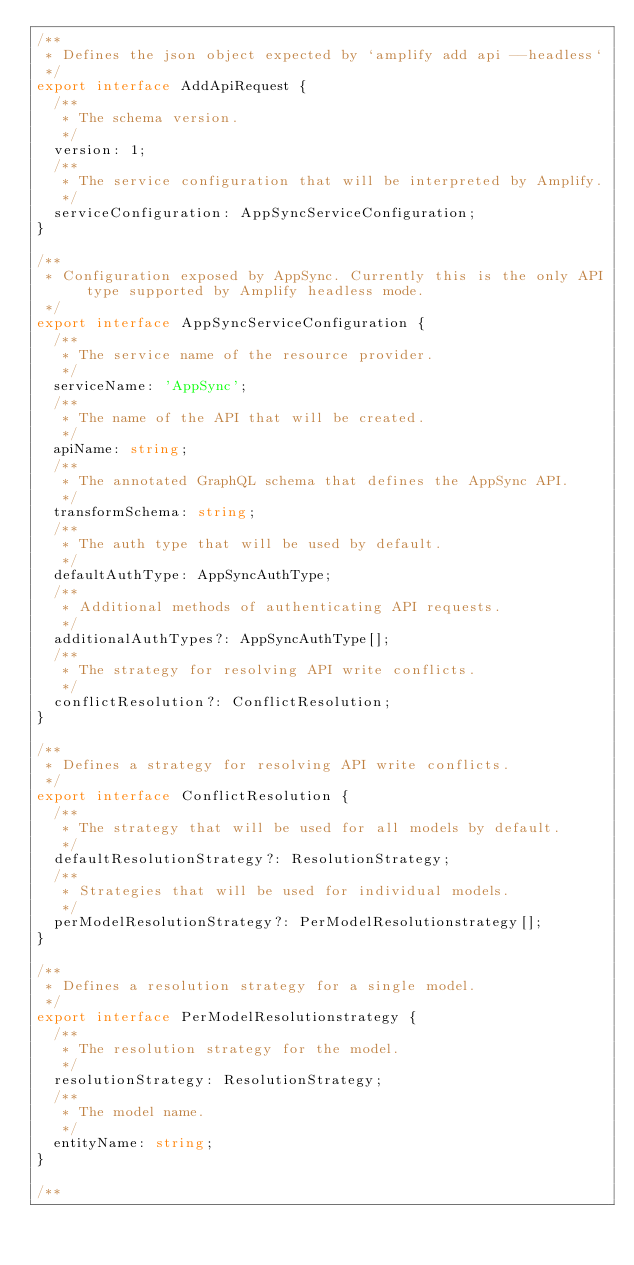Convert code to text. <code><loc_0><loc_0><loc_500><loc_500><_TypeScript_>/**
 * Defines the json object expected by `amplify add api --headless`
 */
export interface AddApiRequest {
  /**
   * The schema version.
   */
  version: 1;
  /**
   * The service configuration that will be interpreted by Amplify.
   */
  serviceConfiguration: AppSyncServiceConfiguration;
}

/**
 * Configuration exposed by AppSync. Currently this is the only API type supported by Amplify headless mode.
 */
export interface AppSyncServiceConfiguration {
  /**
   * The service name of the resource provider.
   */
  serviceName: 'AppSync';
  /**
   * The name of the API that will be created.
   */
  apiName: string;
  /**
   * The annotated GraphQL schema that defines the AppSync API.
   */
  transformSchema: string;
  /**
   * The auth type that will be used by default.
   */
  defaultAuthType: AppSyncAuthType;
  /**
   * Additional methods of authenticating API requests.
   */
  additionalAuthTypes?: AppSyncAuthType[];
  /**
   * The strategy for resolving API write conflicts.
   */
  conflictResolution?: ConflictResolution;
}

/**
 * Defines a strategy for resolving API write conflicts.
 */
export interface ConflictResolution {
  /**
   * The strategy that will be used for all models by default.
   */
  defaultResolutionStrategy?: ResolutionStrategy;
  /**
   * Strategies that will be used for individual models.
   */
  perModelResolutionStrategy?: PerModelResolutionstrategy[];
}

/**
 * Defines a resolution strategy for a single model.
 */
export interface PerModelResolutionstrategy {
  /**
   * The resolution strategy for the model.
   */
  resolutionStrategy: ResolutionStrategy;
  /**
   * The model name.
   */
  entityName: string;
}

/**</code> 